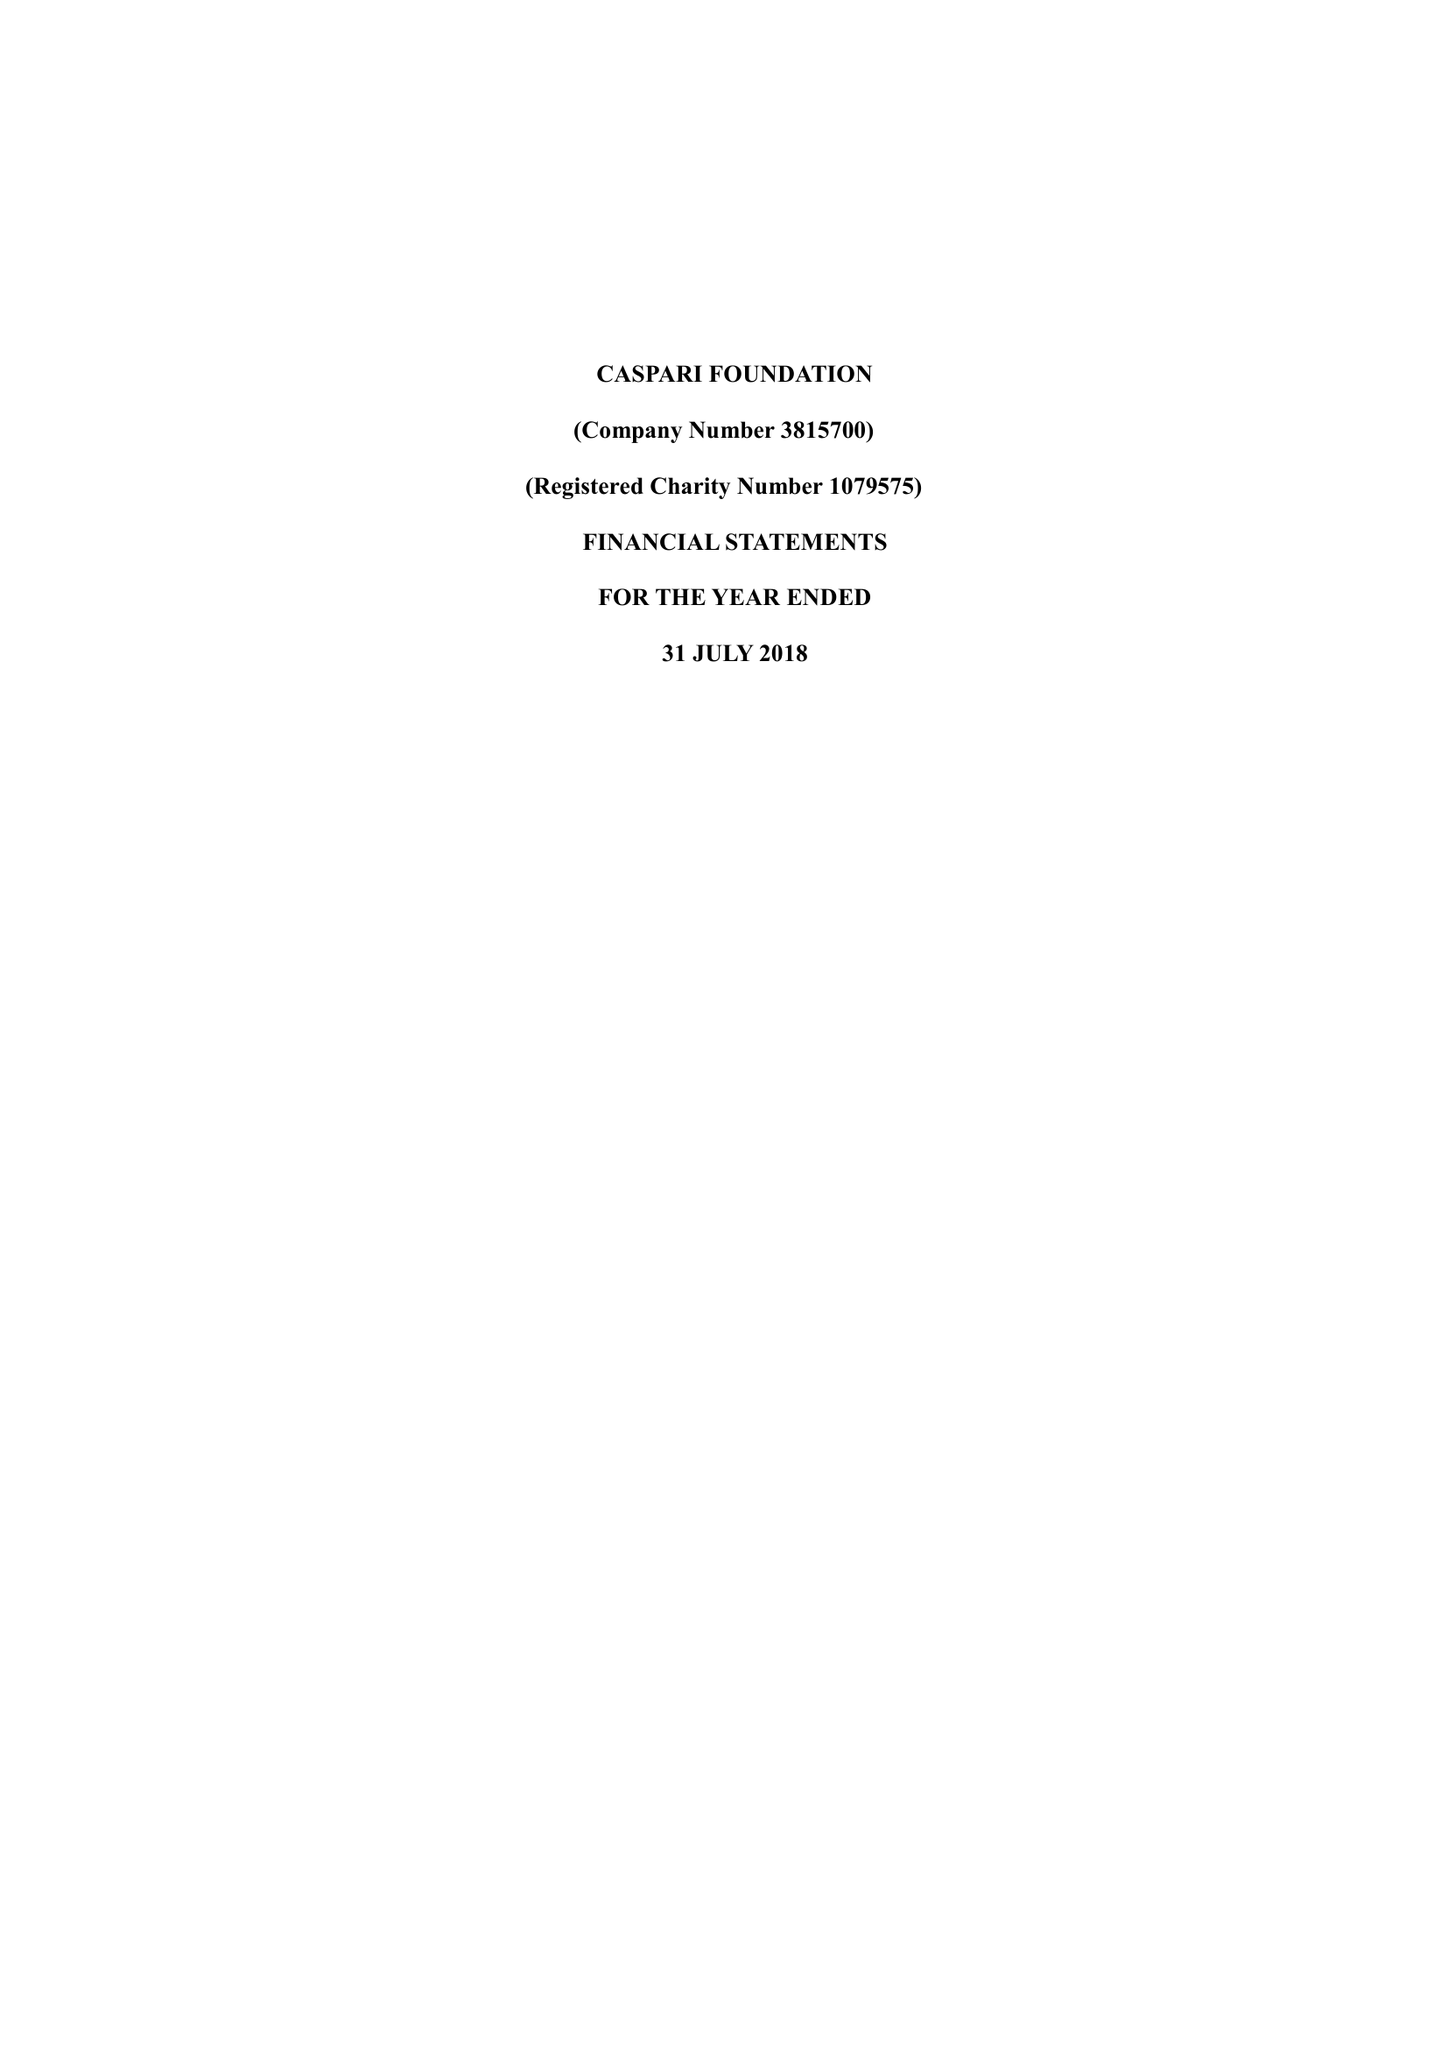What is the value for the charity_name?
Answer the question using a single word or phrase. Caspari Foundation 